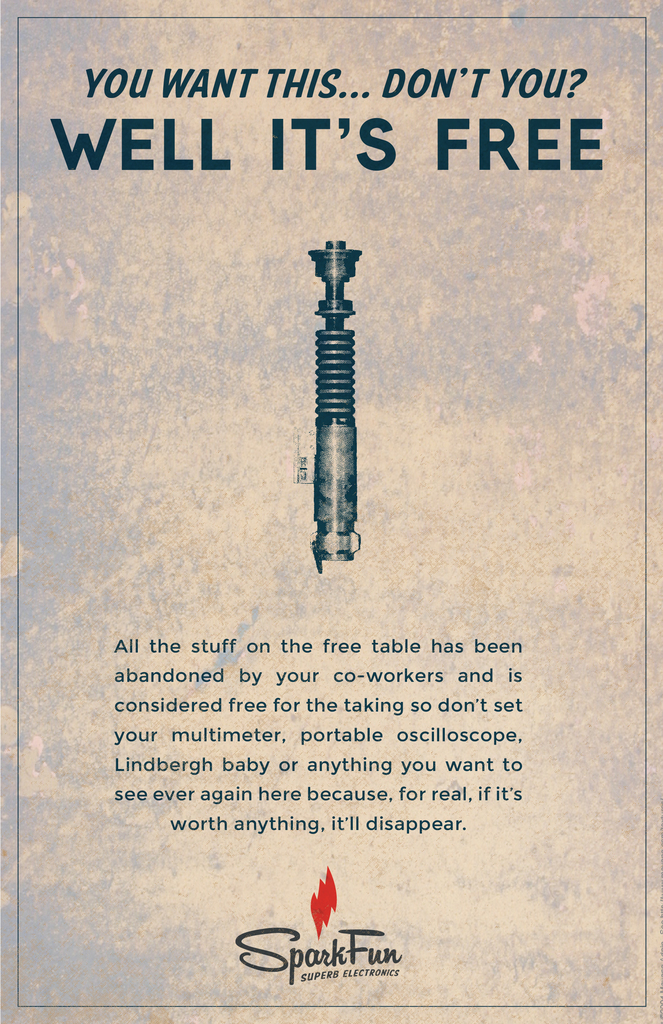How might this advertising approach affect customer perception of SparkFun? This advertising approach could positively affect customer perception by portraying SparkFun as a fun and generous company. It humanizes the brand, making it appear more approachable and relatable, potentially increasing brand loyalty and attracting customers who value community and sustainability. Could this strategy lead to increased sales or is it more about branding? While primarily a branding strategy aimed at enhancing company image and customer connection, this approach can indirectly lead to increased sales. By fostering goodwill and strengthening community ties, it creates a positive brand identity that can attract more customers and encourage repeat purchases. 